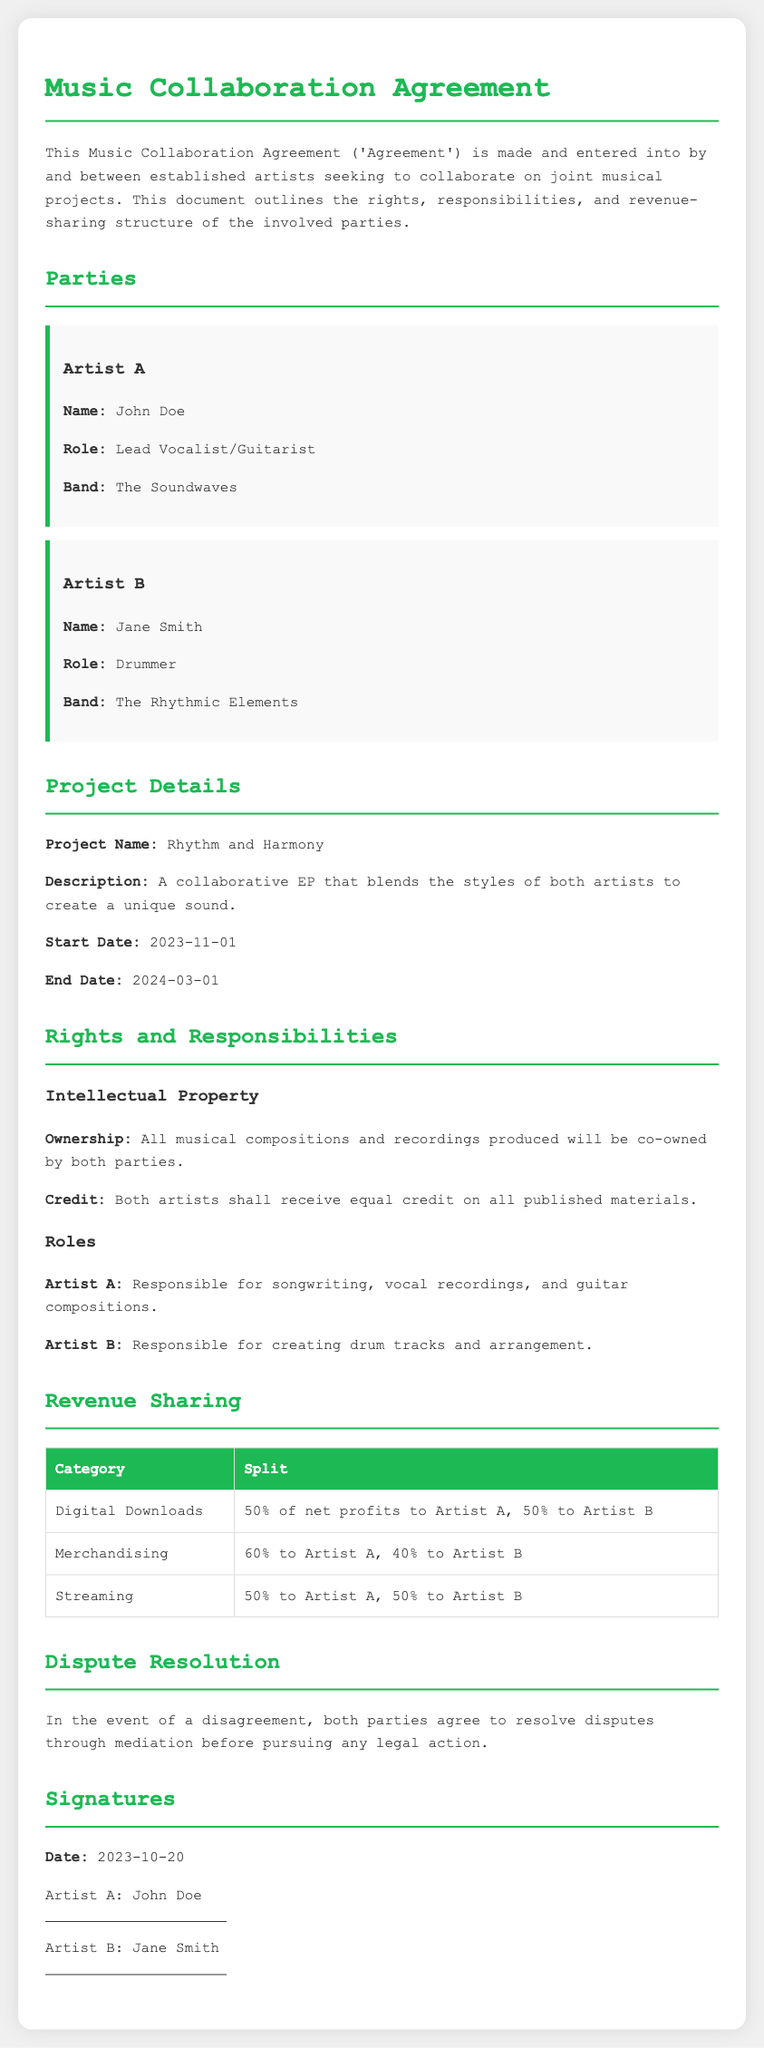What is the project name? The project name is specified in the "Project Details" section of the document.
Answer: Rhythm and Harmony Who is Artist A? The document provides specific information about Artist A in the "Parties" section.
Answer: John Doe What role does Artist B have? Artist B's role is detailed in the "Parties" section of the document.
Answer: Drummer What is the start date of the project? The start date is listed under the "Project Details" section.
Answer: 2023-11-01 What is the revenue split for Merchandising? The revenue sharing details are provided in the "Revenue Sharing" section.
Answer: 60% to Artist A, 40% to Artist B What is the ownership status of musical compositions? The ownership details are specified in the "Rights and Responsibilities" section.
Answer: Co-owned by both parties How will disagreements be resolved? The resolution process is outlined in the "Dispute Resolution" section.
Answer: Mediation What is the end date of the project? The end date can be found in the "Project Details" section of the document.
Answer: 2024-03-01 